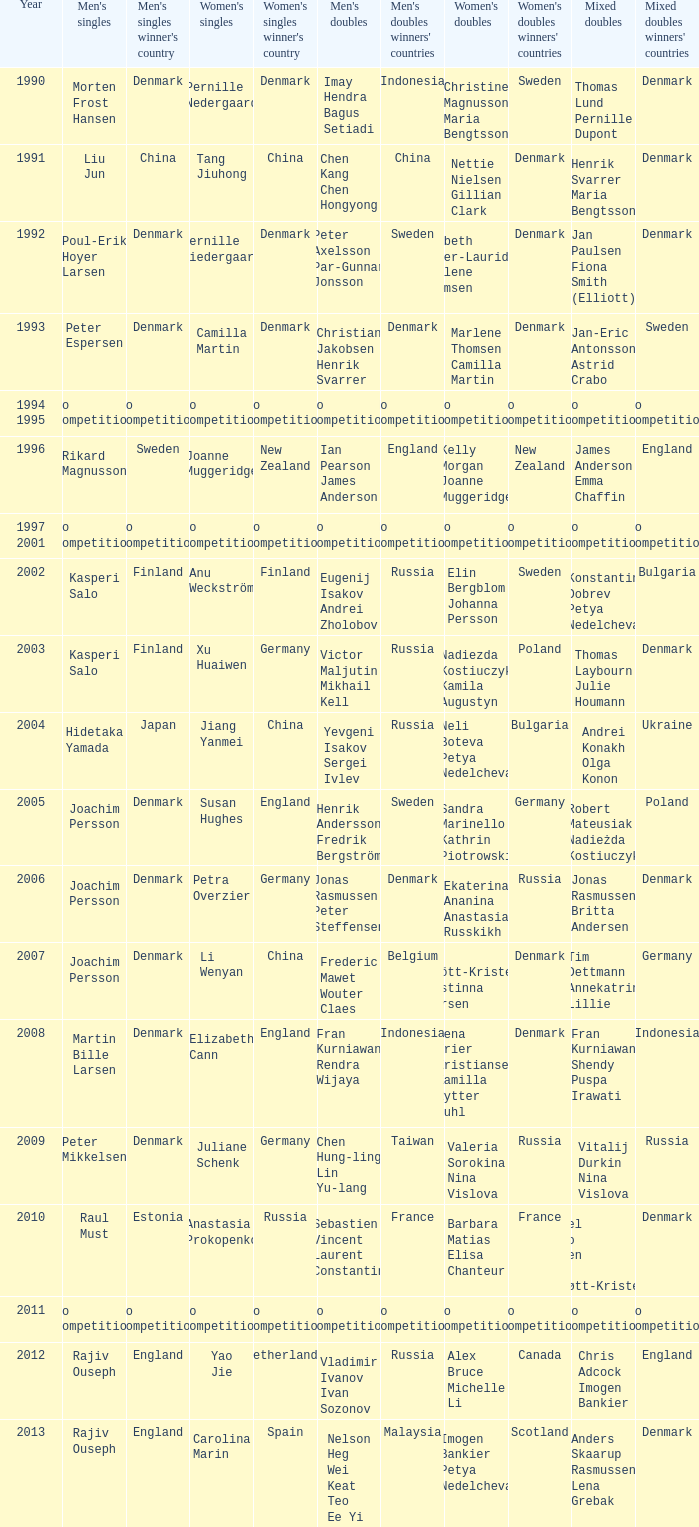Who won the Mixed doubles when Juliane Schenk won the Women's Singles? Vitalij Durkin Nina Vislova. 